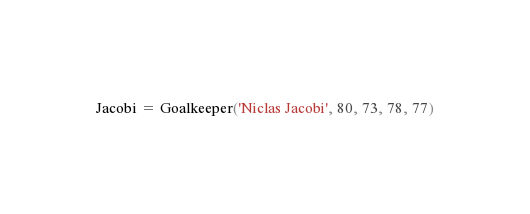<code> <loc_0><loc_0><loc_500><loc_500><_Python_>Jacobi = Goalkeeper('Niclas Jacobi', 80, 73, 78, 77)</code> 